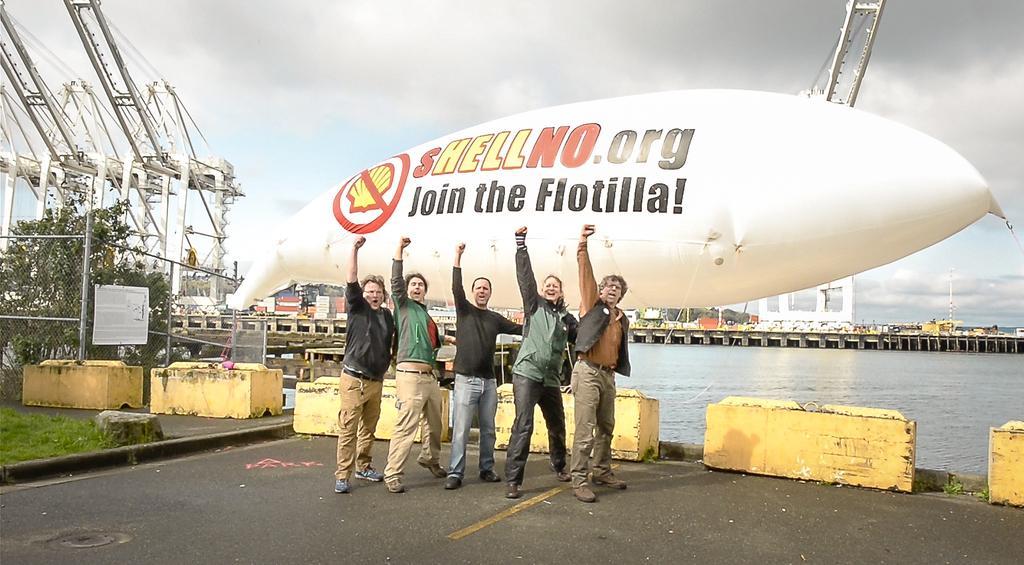How would you summarize this image in a sentence or two? This image is clicked outside. There is water on the right side. There is a balloon in the middle. There are 5 persons standing in the middle. There is a tree on the left side. There is sky at the top. There are buildings in the middle. 